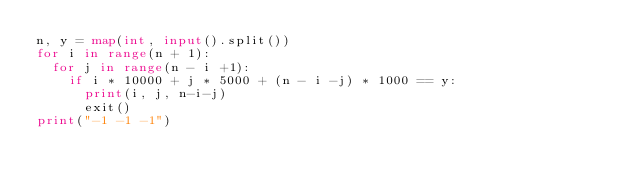Convert code to text. <code><loc_0><loc_0><loc_500><loc_500><_Python_>n, y = map(int, input().split())
for i in range(n + 1):
  for j in range(n - i +1):
    if i * 10000 + j * 5000 + (n - i -j) * 1000 == y:
      print(i, j, n-i-j)
      exit()
print("-1 -1 -1")</code> 